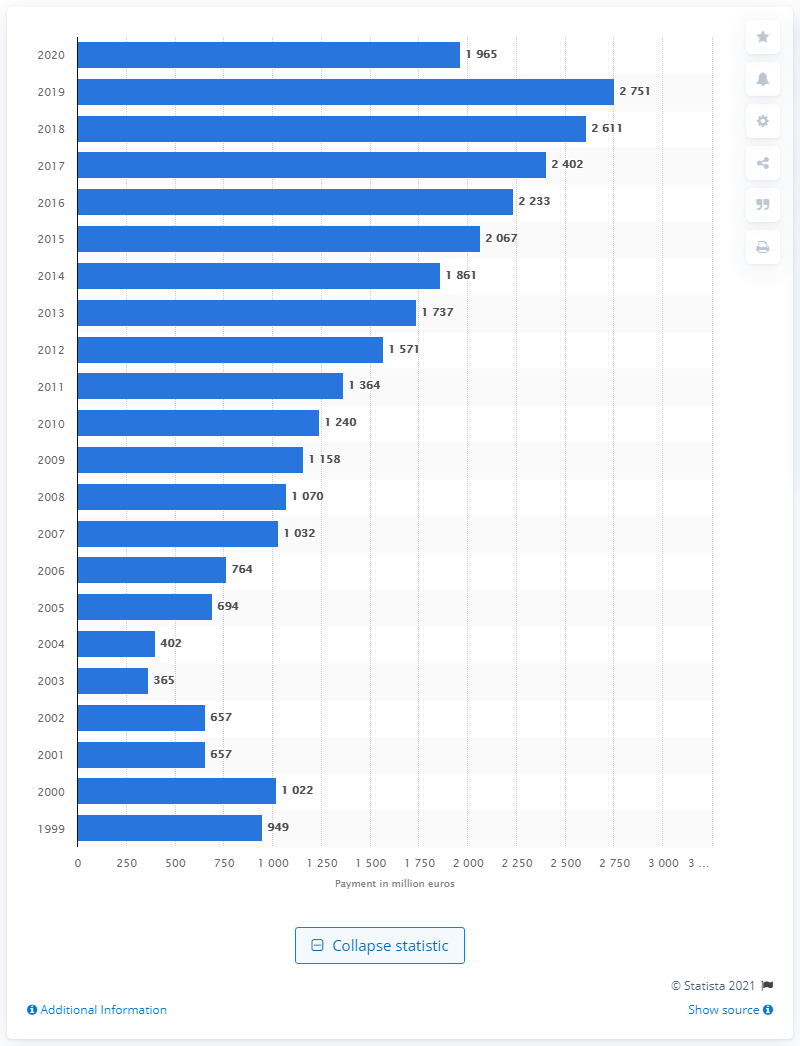Highlight a few significant elements in this photo. In 2020, the total dividend payment of Bayer AG was. 